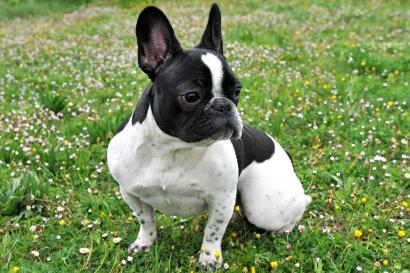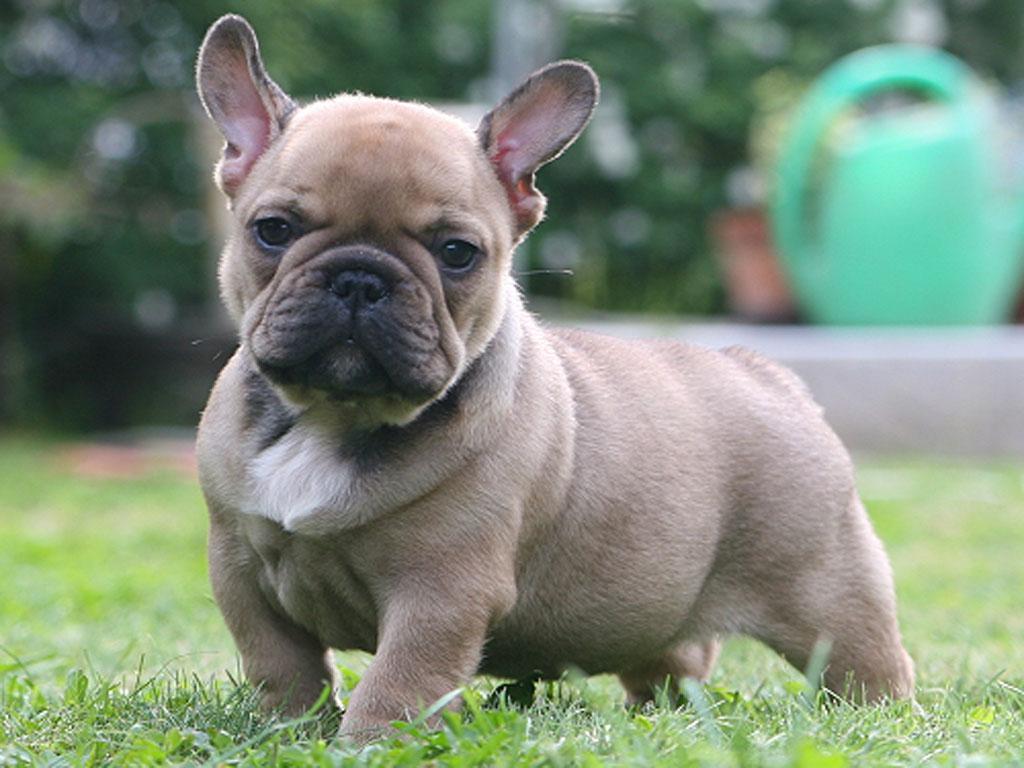The first image is the image on the left, the second image is the image on the right. Examine the images to the left and right. Is the description "At least one dog has black fur on an ear." accurate? Answer yes or no. Yes. 